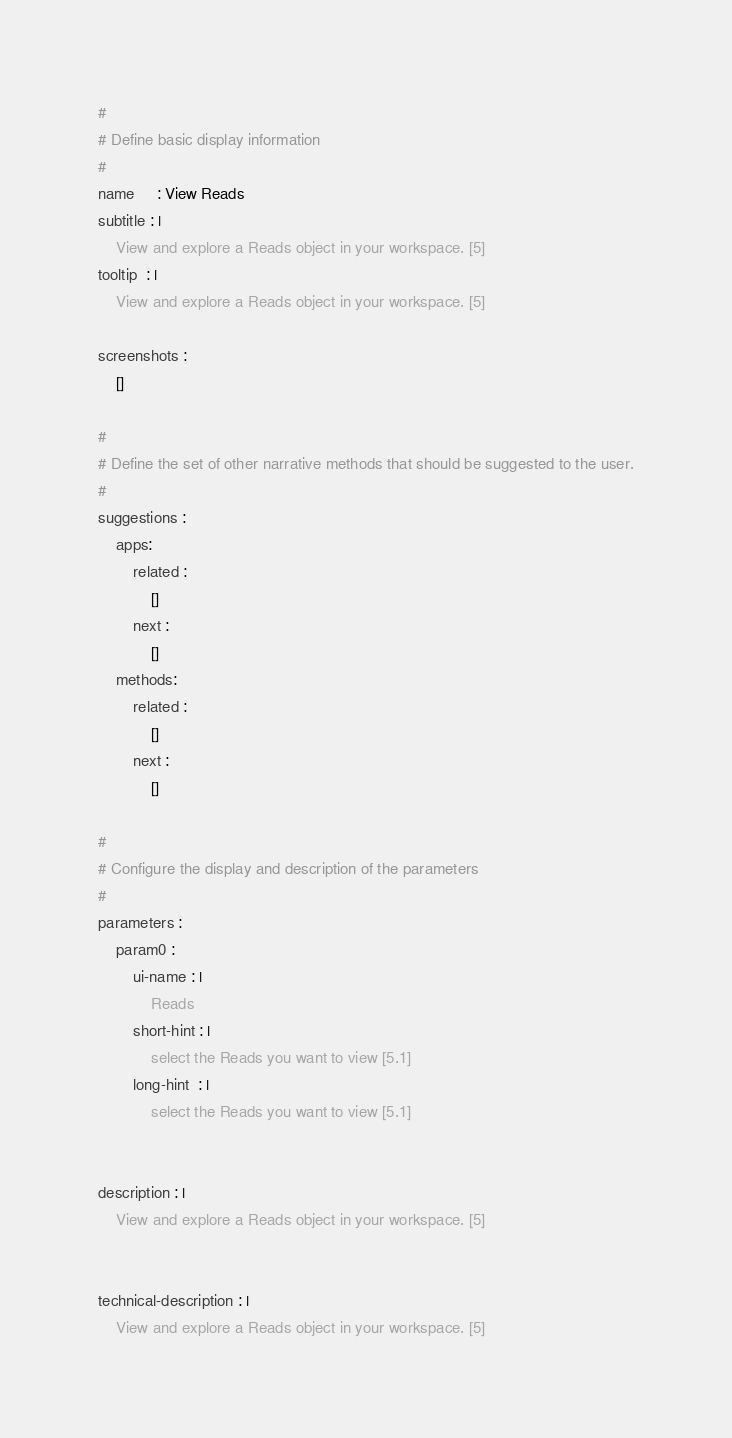<code> <loc_0><loc_0><loc_500><loc_500><_YAML_>#
# Define basic display information
#
name     : View Reads
subtitle : |
    View and explore a Reads object in your workspace. [5]
tooltip  : |
    View and explore a Reads object in your workspace. [5]

screenshots :
    []

#
# Define the set of other narrative methods that should be suggested to the user.
#
suggestions :
    apps:
        related :
            []
        next :
            []
    methods:
        related :
            []
        next :
            []

#
# Configure the display and description of the parameters
#
parameters :
    param0 :
        ui-name : |
            Reads
        short-hint : |
            select the Reads you want to view [5.1]
        long-hint  : |
            select the Reads you want to view [5.1]


description : |
    View and explore a Reads object in your workspace. [5]


technical-description : |
    View and explore a Reads object in your workspace. [5]
</code> 